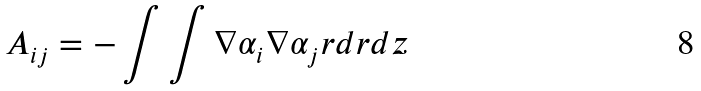<formula> <loc_0><loc_0><loc_500><loc_500>A _ { i j } = - \int \int \nabla \alpha _ { i } \nabla \alpha _ { j } r d r d z</formula> 